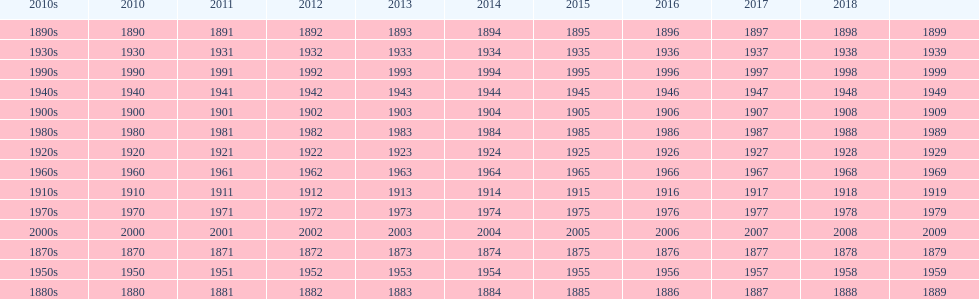True/false: all years go in consecutive order? True. Would you be able to parse every entry in this table? {'header': ['2010s', '2010', '2011', '2012', '2013', '2014', '2015', '2016', '2017', '2018', ''], 'rows': [['1890s', '1890', '1891', '1892', '1893', '1894', '1895', '1896', '1897', '1898', '1899'], ['1930s', '1930', '1931', '1932', '1933', '1934', '1935', '1936', '1937', '1938', '1939'], ['1990s', '1990', '1991', '1992', '1993', '1994', '1995', '1996', '1997', '1998', '1999'], ['1940s', '1940', '1941', '1942', '1943', '1944', '1945', '1946', '1947', '1948', '1949'], ['1900s', '1900', '1901', '1902', '1903', '1904', '1905', '1906', '1907', '1908', '1909'], ['1980s', '1980', '1981', '1982', '1983', '1984', '1985', '1986', '1987', '1988', '1989'], ['1920s', '1920', '1921', '1922', '1923', '1924', '1925', '1926', '1927', '1928', '1929'], ['1960s', '1960', '1961', '1962', '1963', '1964', '1965', '1966', '1967', '1968', '1969'], ['1910s', '1910', '1911', '1912', '1913', '1914', '1915', '1916', '1917', '1918', '1919'], ['1970s', '1970', '1971', '1972', '1973', '1974', '1975', '1976', '1977', '1978', '1979'], ['2000s', '2000', '2001', '2002', '2003', '2004', '2005', '2006', '2007', '2008', '2009'], ['1870s', '1870', '1871', '1872', '1873', '1874', '1875', '1876', '1877', '1878', '1879'], ['1950s', '1950', '1951', '1952', '1953', '1954', '1955', '1956', '1957', '1958', '1959'], ['1880s', '1880', '1881', '1882', '1883', '1884', '1885', '1886', '1887', '1888', '1889']]} 